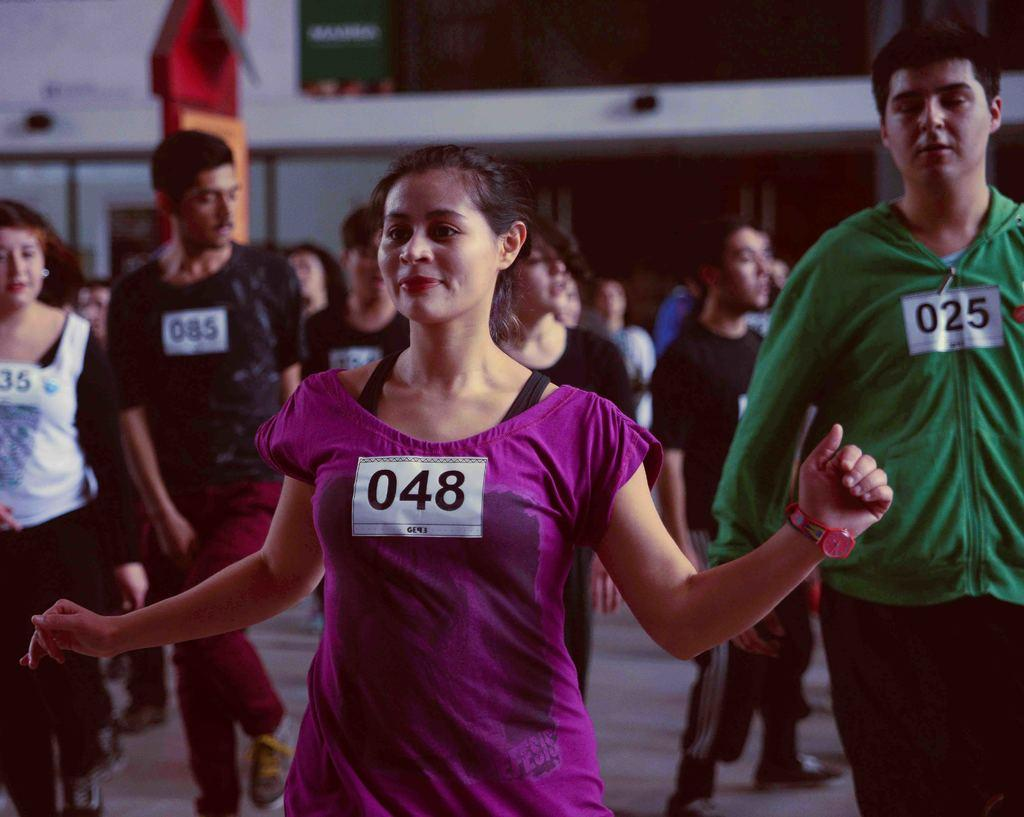What types of people are in the image? There are both men and women in the image. Can you describe the clothing of one of the women? Yes, there is a woman wearing a violet color t-shirt. Where is the man positioned in the image? There is a man standing on the right side of the image. What type of writing can be seen on the cactus in the image? There is no cactus present in the image, so no writing can be seen on it. 